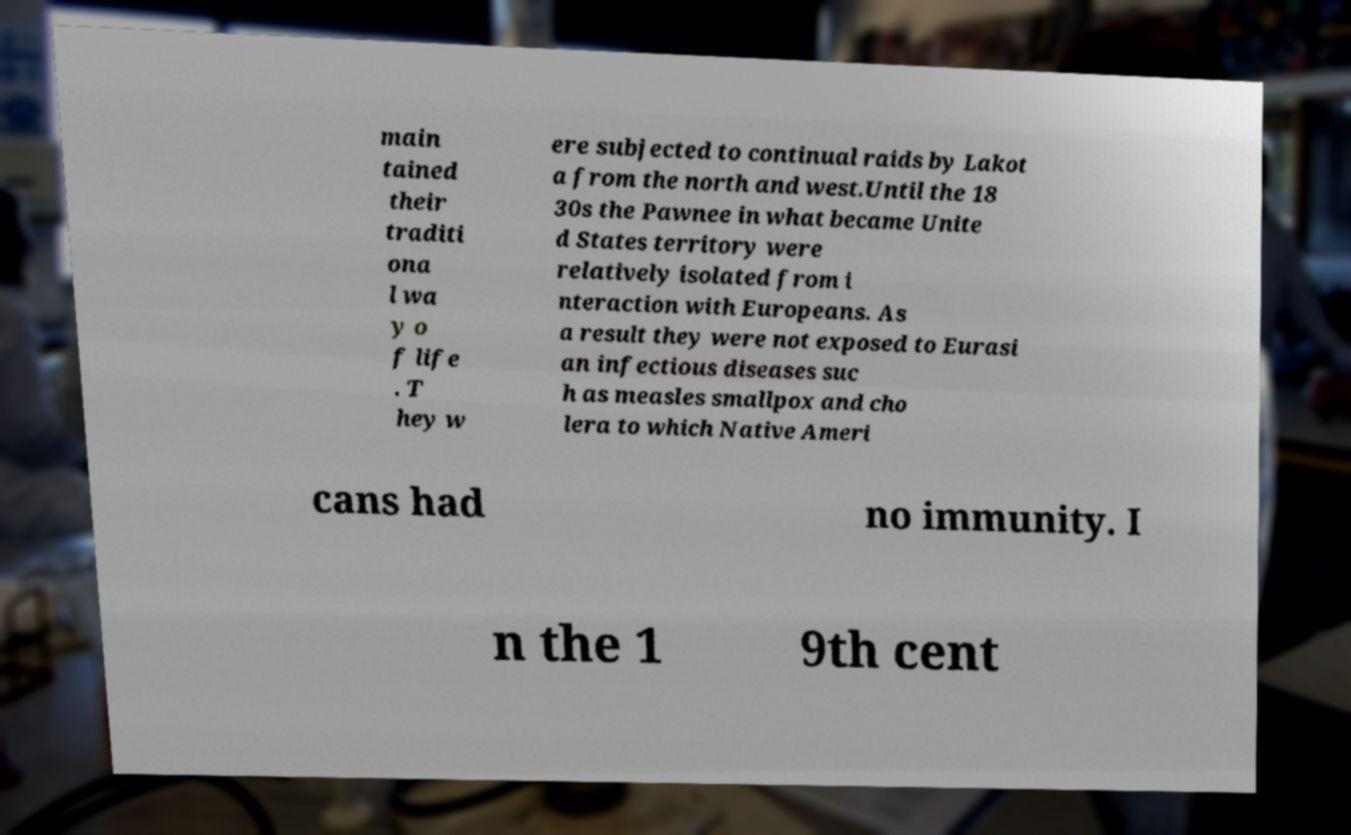Could you extract and type out the text from this image? main tained their traditi ona l wa y o f life . T hey w ere subjected to continual raids by Lakot a from the north and west.Until the 18 30s the Pawnee in what became Unite d States territory were relatively isolated from i nteraction with Europeans. As a result they were not exposed to Eurasi an infectious diseases suc h as measles smallpox and cho lera to which Native Ameri cans had no immunity. I n the 1 9th cent 